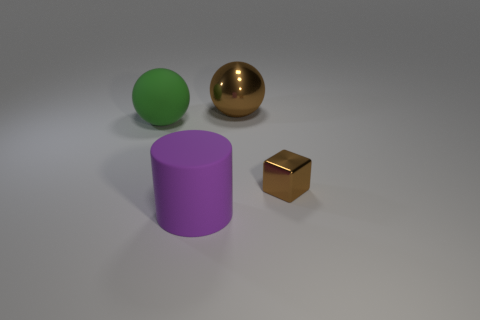How many small objects are brown things or green things?
Keep it short and to the point. 1. What number of objects are large balls to the left of the big purple rubber cylinder or tiny metal things that are in front of the big green matte ball?
Your answer should be compact. 2. Is the number of purple cylinders less than the number of big gray balls?
Keep it short and to the point. No. What is the shape of the green matte object that is the same size as the purple rubber cylinder?
Offer a terse response. Sphere. How many other objects are the same color as the matte cylinder?
Offer a terse response. 0. How many tiny yellow metal balls are there?
Keep it short and to the point. 0. How many things are both on the left side of the tiny cube and in front of the brown metallic sphere?
Ensure brevity in your answer.  2. What is the green thing made of?
Provide a short and direct response. Rubber. Are there any metallic blocks?
Make the answer very short. Yes. What color is the large rubber object in front of the tiny shiny thing?
Your response must be concise. Purple. 